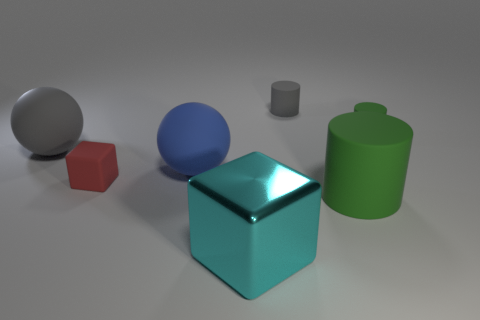How many other matte objects have the same shape as the big cyan object?
Your response must be concise. 1. How big is the green matte object on the right side of the cylinder in front of the green matte cylinder behind the large blue ball?
Offer a terse response. Small. What number of purple objects are either big balls or big blocks?
Keep it short and to the point. 0. There is a small rubber object that is left of the gray matte cylinder; is its shape the same as the tiny green matte object?
Your answer should be compact. No. Are there more tiny gray objects that are to the left of the red rubber thing than small green objects?
Your answer should be compact. No. How many objects are the same size as the cyan metallic block?
Provide a short and direct response. 3. What is the size of the rubber thing that is the same color as the big cylinder?
Offer a terse response. Small. How many objects are either big yellow matte cylinders or small rubber things that are to the left of the metal block?
Provide a short and direct response. 1. What is the color of the tiny object that is in front of the gray cylinder and left of the large green cylinder?
Offer a terse response. Red. Do the cyan metal thing and the blue object have the same size?
Your answer should be compact. Yes. 